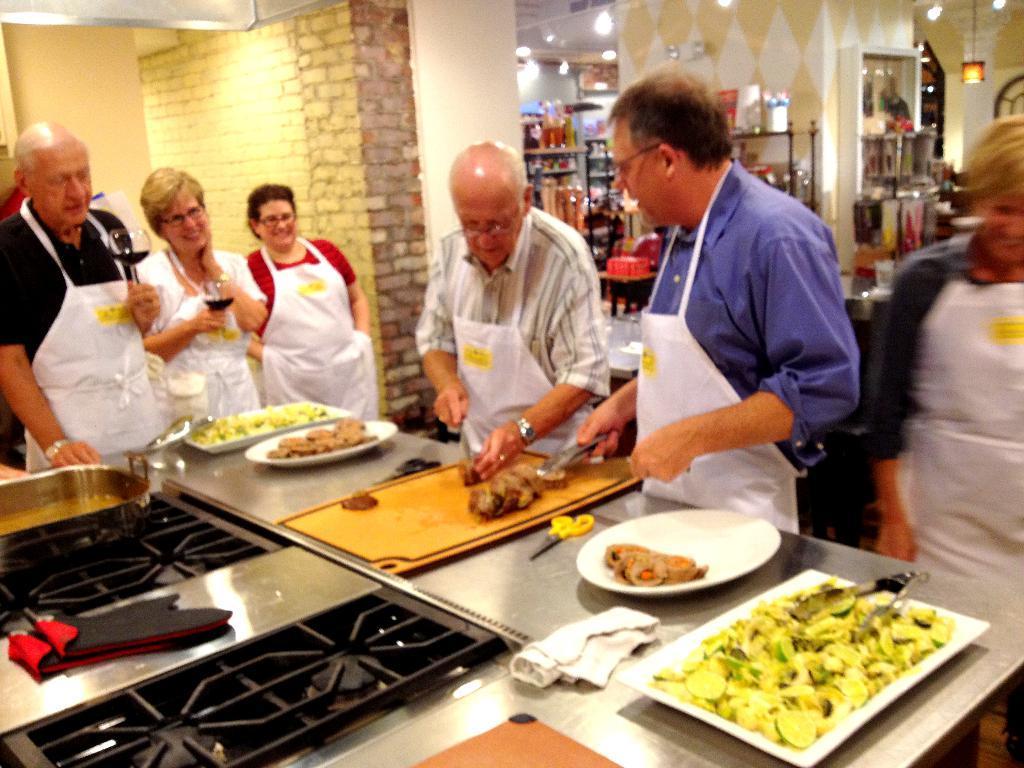In one or two sentences, can you explain what this image depicts? In the picture we can see inside view of the kitchen with a stove and the desk near it and we can see a man standing and chopping some vegetables and beside him we can see three people are standing and watching it and in the background we can see some items are placed in the rack and to the ceiling we can see some lights. 